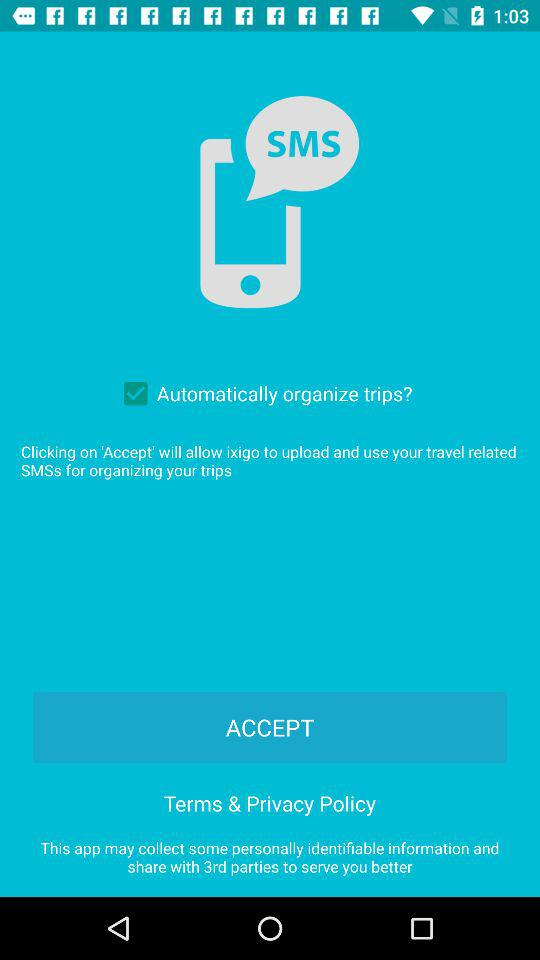What is the status of "Automatically organize trips?"? The status is "on". 